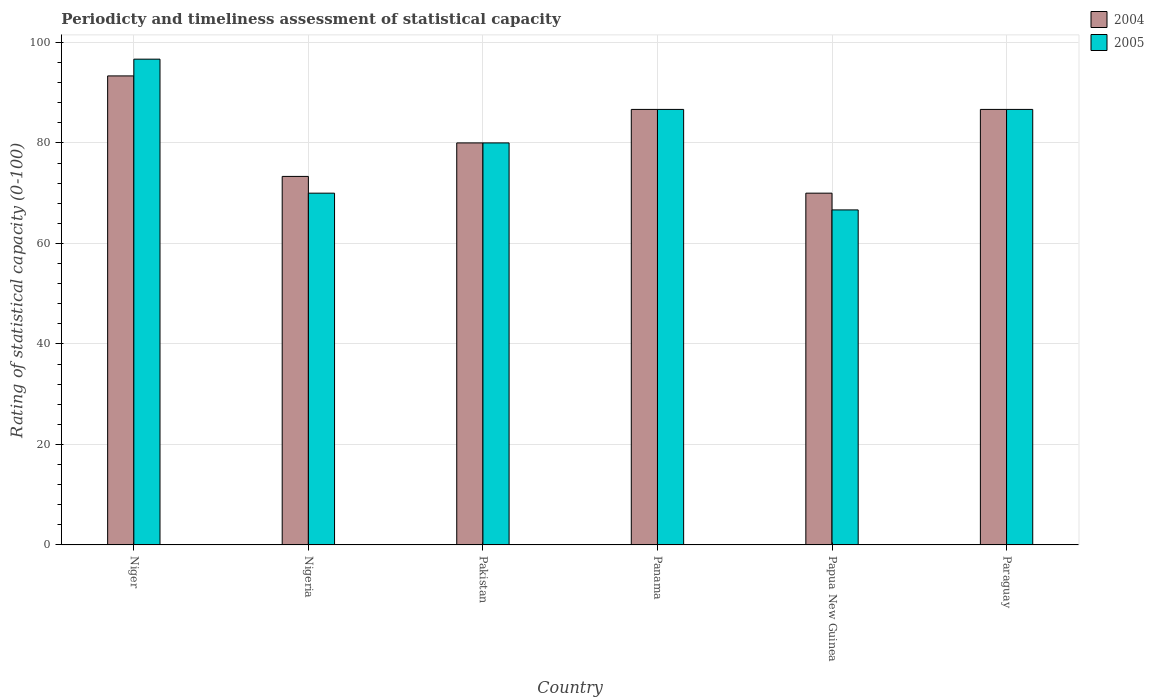How many groups of bars are there?
Make the answer very short. 6. Are the number of bars per tick equal to the number of legend labels?
Your answer should be compact. Yes. Are the number of bars on each tick of the X-axis equal?
Provide a short and direct response. Yes. What is the label of the 2nd group of bars from the left?
Make the answer very short. Nigeria. In how many cases, is the number of bars for a given country not equal to the number of legend labels?
Give a very brief answer. 0. What is the rating of statistical capacity in 2005 in Panama?
Keep it short and to the point. 86.67. Across all countries, what is the maximum rating of statistical capacity in 2004?
Keep it short and to the point. 93.33. In which country was the rating of statistical capacity in 2005 maximum?
Provide a succinct answer. Niger. In which country was the rating of statistical capacity in 2004 minimum?
Provide a short and direct response. Papua New Guinea. What is the total rating of statistical capacity in 2004 in the graph?
Keep it short and to the point. 490. What is the difference between the rating of statistical capacity in 2005 in Niger and that in Pakistan?
Offer a terse response. 16.67. What is the difference between the rating of statistical capacity in 2004 in Pakistan and the rating of statistical capacity in 2005 in Panama?
Offer a very short reply. -6.67. What is the average rating of statistical capacity in 2005 per country?
Provide a short and direct response. 81.11. What is the difference between the rating of statistical capacity of/in 2004 and rating of statistical capacity of/in 2005 in Nigeria?
Make the answer very short. 3.33. In how many countries, is the rating of statistical capacity in 2004 greater than 80?
Provide a succinct answer. 3. What is the ratio of the rating of statistical capacity in 2004 in Panama to that in Paraguay?
Give a very brief answer. 1. Is the difference between the rating of statistical capacity in 2004 in Niger and Paraguay greater than the difference between the rating of statistical capacity in 2005 in Niger and Paraguay?
Keep it short and to the point. No. What is the difference between the highest and the second highest rating of statistical capacity in 2005?
Provide a short and direct response. 10. In how many countries, is the rating of statistical capacity in 2005 greater than the average rating of statistical capacity in 2005 taken over all countries?
Provide a succinct answer. 3. What does the 2nd bar from the right in Papua New Guinea represents?
Ensure brevity in your answer.  2004. How many bars are there?
Your answer should be very brief. 12. How many countries are there in the graph?
Offer a terse response. 6. Does the graph contain any zero values?
Keep it short and to the point. No. Does the graph contain grids?
Keep it short and to the point. Yes. How are the legend labels stacked?
Provide a short and direct response. Vertical. What is the title of the graph?
Your answer should be very brief. Periodicty and timeliness assessment of statistical capacity. Does "1973" appear as one of the legend labels in the graph?
Provide a short and direct response. No. What is the label or title of the X-axis?
Make the answer very short. Country. What is the label or title of the Y-axis?
Ensure brevity in your answer.  Rating of statistical capacity (0-100). What is the Rating of statistical capacity (0-100) of 2004 in Niger?
Give a very brief answer. 93.33. What is the Rating of statistical capacity (0-100) of 2005 in Niger?
Your response must be concise. 96.67. What is the Rating of statistical capacity (0-100) of 2004 in Nigeria?
Your answer should be compact. 73.33. What is the Rating of statistical capacity (0-100) of 2004 in Panama?
Make the answer very short. 86.67. What is the Rating of statistical capacity (0-100) of 2005 in Panama?
Keep it short and to the point. 86.67. What is the Rating of statistical capacity (0-100) in 2004 in Papua New Guinea?
Provide a succinct answer. 70. What is the Rating of statistical capacity (0-100) of 2005 in Papua New Guinea?
Make the answer very short. 66.67. What is the Rating of statistical capacity (0-100) in 2004 in Paraguay?
Offer a terse response. 86.67. What is the Rating of statistical capacity (0-100) of 2005 in Paraguay?
Provide a short and direct response. 86.67. Across all countries, what is the maximum Rating of statistical capacity (0-100) in 2004?
Give a very brief answer. 93.33. Across all countries, what is the maximum Rating of statistical capacity (0-100) of 2005?
Keep it short and to the point. 96.67. Across all countries, what is the minimum Rating of statistical capacity (0-100) of 2005?
Your answer should be compact. 66.67. What is the total Rating of statistical capacity (0-100) of 2004 in the graph?
Provide a succinct answer. 490. What is the total Rating of statistical capacity (0-100) of 2005 in the graph?
Your answer should be very brief. 486.67. What is the difference between the Rating of statistical capacity (0-100) in 2005 in Niger and that in Nigeria?
Your answer should be very brief. 26.67. What is the difference between the Rating of statistical capacity (0-100) in 2004 in Niger and that in Pakistan?
Keep it short and to the point. 13.33. What is the difference between the Rating of statistical capacity (0-100) of 2005 in Niger and that in Pakistan?
Make the answer very short. 16.67. What is the difference between the Rating of statistical capacity (0-100) in 2004 in Niger and that in Panama?
Ensure brevity in your answer.  6.67. What is the difference between the Rating of statistical capacity (0-100) of 2005 in Niger and that in Panama?
Make the answer very short. 10. What is the difference between the Rating of statistical capacity (0-100) in 2004 in Niger and that in Papua New Guinea?
Keep it short and to the point. 23.33. What is the difference between the Rating of statistical capacity (0-100) in 2005 in Niger and that in Papua New Guinea?
Provide a short and direct response. 30. What is the difference between the Rating of statistical capacity (0-100) of 2004 in Nigeria and that in Pakistan?
Make the answer very short. -6.67. What is the difference between the Rating of statistical capacity (0-100) of 2004 in Nigeria and that in Panama?
Make the answer very short. -13.33. What is the difference between the Rating of statistical capacity (0-100) of 2005 in Nigeria and that in Panama?
Provide a short and direct response. -16.67. What is the difference between the Rating of statistical capacity (0-100) of 2004 in Nigeria and that in Papua New Guinea?
Offer a very short reply. 3.33. What is the difference between the Rating of statistical capacity (0-100) of 2004 in Nigeria and that in Paraguay?
Provide a succinct answer. -13.33. What is the difference between the Rating of statistical capacity (0-100) of 2005 in Nigeria and that in Paraguay?
Provide a succinct answer. -16.67. What is the difference between the Rating of statistical capacity (0-100) in 2004 in Pakistan and that in Panama?
Give a very brief answer. -6.67. What is the difference between the Rating of statistical capacity (0-100) in 2005 in Pakistan and that in Panama?
Keep it short and to the point. -6.67. What is the difference between the Rating of statistical capacity (0-100) in 2004 in Pakistan and that in Papua New Guinea?
Offer a very short reply. 10. What is the difference between the Rating of statistical capacity (0-100) of 2005 in Pakistan and that in Papua New Guinea?
Keep it short and to the point. 13.33. What is the difference between the Rating of statistical capacity (0-100) in 2004 in Pakistan and that in Paraguay?
Offer a very short reply. -6.67. What is the difference between the Rating of statistical capacity (0-100) in 2005 in Pakistan and that in Paraguay?
Your answer should be very brief. -6.67. What is the difference between the Rating of statistical capacity (0-100) of 2004 in Panama and that in Papua New Guinea?
Provide a succinct answer. 16.67. What is the difference between the Rating of statistical capacity (0-100) in 2005 in Panama and that in Papua New Guinea?
Your answer should be compact. 20. What is the difference between the Rating of statistical capacity (0-100) of 2005 in Panama and that in Paraguay?
Provide a short and direct response. 0. What is the difference between the Rating of statistical capacity (0-100) in 2004 in Papua New Guinea and that in Paraguay?
Provide a succinct answer. -16.67. What is the difference between the Rating of statistical capacity (0-100) of 2004 in Niger and the Rating of statistical capacity (0-100) of 2005 in Nigeria?
Ensure brevity in your answer.  23.33. What is the difference between the Rating of statistical capacity (0-100) of 2004 in Niger and the Rating of statistical capacity (0-100) of 2005 in Pakistan?
Your answer should be very brief. 13.33. What is the difference between the Rating of statistical capacity (0-100) of 2004 in Niger and the Rating of statistical capacity (0-100) of 2005 in Panama?
Make the answer very short. 6.67. What is the difference between the Rating of statistical capacity (0-100) in 2004 in Niger and the Rating of statistical capacity (0-100) in 2005 in Papua New Guinea?
Your answer should be compact. 26.67. What is the difference between the Rating of statistical capacity (0-100) of 2004 in Nigeria and the Rating of statistical capacity (0-100) of 2005 in Pakistan?
Your answer should be compact. -6.67. What is the difference between the Rating of statistical capacity (0-100) of 2004 in Nigeria and the Rating of statistical capacity (0-100) of 2005 in Panama?
Keep it short and to the point. -13.33. What is the difference between the Rating of statistical capacity (0-100) in 2004 in Nigeria and the Rating of statistical capacity (0-100) in 2005 in Paraguay?
Give a very brief answer. -13.33. What is the difference between the Rating of statistical capacity (0-100) of 2004 in Pakistan and the Rating of statistical capacity (0-100) of 2005 in Panama?
Your answer should be very brief. -6.67. What is the difference between the Rating of statistical capacity (0-100) in 2004 in Pakistan and the Rating of statistical capacity (0-100) in 2005 in Papua New Guinea?
Provide a short and direct response. 13.33. What is the difference between the Rating of statistical capacity (0-100) of 2004 in Pakistan and the Rating of statistical capacity (0-100) of 2005 in Paraguay?
Your response must be concise. -6.67. What is the difference between the Rating of statistical capacity (0-100) in 2004 in Panama and the Rating of statistical capacity (0-100) in 2005 in Paraguay?
Your answer should be compact. 0. What is the difference between the Rating of statistical capacity (0-100) in 2004 in Papua New Guinea and the Rating of statistical capacity (0-100) in 2005 in Paraguay?
Ensure brevity in your answer.  -16.67. What is the average Rating of statistical capacity (0-100) of 2004 per country?
Your response must be concise. 81.67. What is the average Rating of statistical capacity (0-100) of 2005 per country?
Ensure brevity in your answer.  81.11. What is the difference between the Rating of statistical capacity (0-100) of 2004 and Rating of statistical capacity (0-100) of 2005 in Panama?
Make the answer very short. 0. What is the difference between the Rating of statistical capacity (0-100) in 2004 and Rating of statistical capacity (0-100) in 2005 in Papua New Guinea?
Your response must be concise. 3.33. What is the ratio of the Rating of statistical capacity (0-100) in 2004 in Niger to that in Nigeria?
Ensure brevity in your answer.  1.27. What is the ratio of the Rating of statistical capacity (0-100) in 2005 in Niger to that in Nigeria?
Offer a terse response. 1.38. What is the ratio of the Rating of statistical capacity (0-100) in 2005 in Niger to that in Pakistan?
Keep it short and to the point. 1.21. What is the ratio of the Rating of statistical capacity (0-100) in 2005 in Niger to that in Panama?
Offer a very short reply. 1.12. What is the ratio of the Rating of statistical capacity (0-100) of 2004 in Niger to that in Papua New Guinea?
Offer a terse response. 1.33. What is the ratio of the Rating of statistical capacity (0-100) of 2005 in Niger to that in Papua New Guinea?
Ensure brevity in your answer.  1.45. What is the ratio of the Rating of statistical capacity (0-100) of 2005 in Niger to that in Paraguay?
Provide a succinct answer. 1.12. What is the ratio of the Rating of statistical capacity (0-100) in 2004 in Nigeria to that in Pakistan?
Give a very brief answer. 0.92. What is the ratio of the Rating of statistical capacity (0-100) in 2004 in Nigeria to that in Panama?
Give a very brief answer. 0.85. What is the ratio of the Rating of statistical capacity (0-100) in 2005 in Nigeria to that in Panama?
Offer a very short reply. 0.81. What is the ratio of the Rating of statistical capacity (0-100) in 2004 in Nigeria to that in Papua New Guinea?
Make the answer very short. 1.05. What is the ratio of the Rating of statistical capacity (0-100) of 2004 in Nigeria to that in Paraguay?
Give a very brief answer. 0.85. What is the ratio of the Rating of statistical capacity (0-100) in 2005 in Nigeria to that in Paraguay?
Offer a terse response. 0.81. What is the ratio of the Rating of statistical capacity (0-100) in 2004 in Pakistan to that in Panama?
Offer a terse response. 0.92. What is the ratio of the Rating of statistical capacity (0-100) of 2005 in Pakistan to that in Panama?
Ensure brevity in your answer.  0.92. What is the ratio of the Rating of statistical capacity (0-100) of 2004 in Pakistan to that in Paraguay?
Your response must be concise. 0.92. What is the ratio of the Rating of statistical capacity (0-100) of 2004 in Panama to that in Papua New Guinea?
Your response must be concise. 1.24. What is the ratio of the Rating of statistical capacity (0-100) in 2005 in Panama to that in Papua New Guinea?
Provide a succinct answer. 1.3. What is the ratio of the Rating of statistical capacity (0-100) of 2004 in Panama to that in Paraguay?
Provide a succinct answer. 1. What is the ratio of the Rating of statistical capacity (0-100) of 2005 in Panama to that in Paraguay?
Ensure brevity in your answer.  1. What is the ratio of the Rating of statistical capacity (0-100) in 2004 in Papua New Guinea to that in Paraguay?
Provide a succinct answer. 0.81. What is the ratio of the Rating of statistical capacity (0-100) of 2005 in Papua New Guinea to that in Paraguay?
Offer a very short reply. 0.77. What is the difference between the highest and the second highest Rating of statistical capacity (0-100) of 2004?
Your answer should be very brief. 6.67. What is the difference between the highest and the lowest Rating of statistical capacity (0-100) in 2004?
Your answer should be compact. 23.33. What is the difference between the highest and the lowest Rating of statistical capacity (0-100) in 2005?
Your answer should be very brief. 30. 